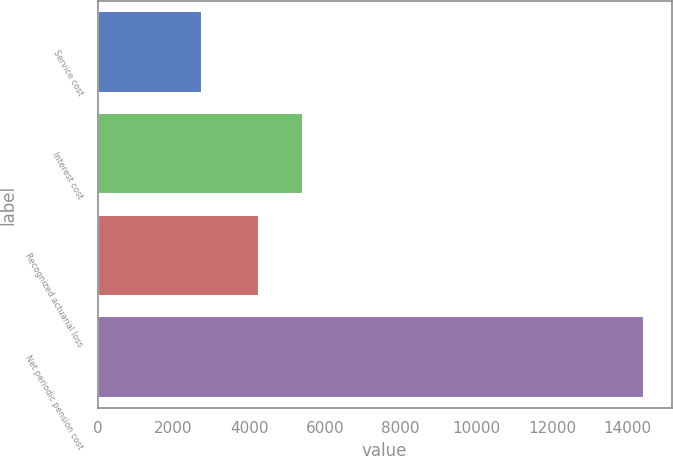Convert chart. <chart><loc_0><loc_0><loc_500><loc_500><bar_chart><fcel>Service cost<fcel>Interest cost<fcel>Recognized actuarial loss<fcel>Net periodic pension cost<nl><fcel>2756<fcel>5419<fcel>4251<fcel>14436<nl></chart> 